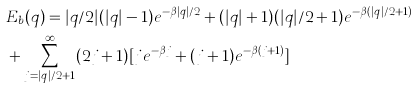Convert formula to latex. <formula><loc_0><loc_0><loc_500><loc_500>& E _ { b } ( q ) = | q / 2 | ( | q | - 1 ) e ^ { - \beta | q | / 2 } + ( | q | + 1 ) ( | q | / 2 + 1 ) e ^ { - \beta ( | q | / 2 + 1 ) } \\ & + \sum _ { j = | q | / 2 + 1 } ^ { \infty } ( 2 j + 1 ) [ j e ^ { - \beta j } + ( j + 1 ) e ^ { - \beta ( j + 1 ) } ]</formula> 